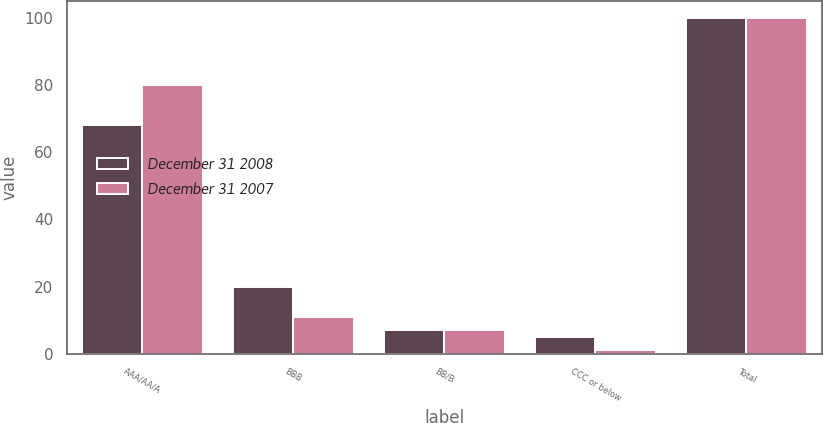<chart> <loc_0><loc_0><loc_500><loc_500><stacked_bar_chart><ecel><fcel>AAA/AA/A<fcel>BBB<fcel>BB/B<fcel>CCC or below<fcel>Total<nl><fcel>December 31 2008<fcel>68<fcel>20<fcel>7<fcel>5<fcel>100<nl><fcel>December 31 2007<fcel>80<fcel>11<fcel>7<fcel>1<fcel>100<nl></chart> 